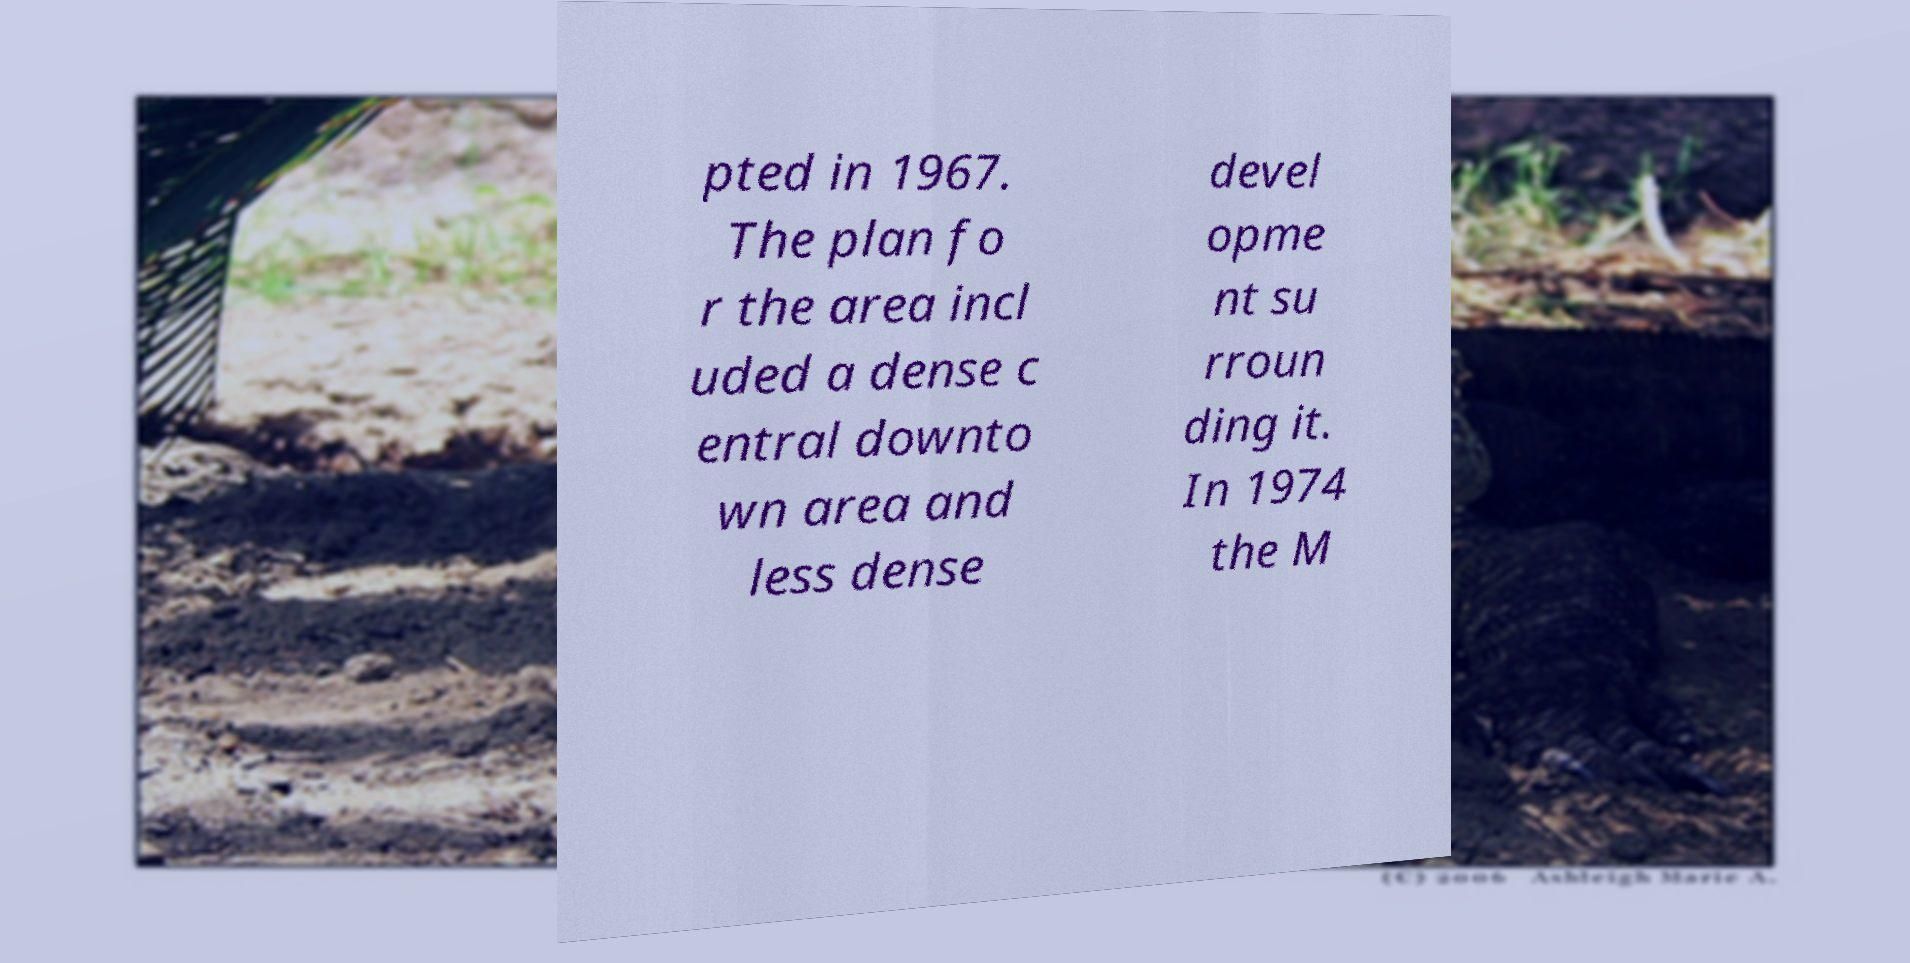Please read and relay the text visible in this image. What does it say? pted in 1967. The plan fo r the area incl uded a dense c entral downto wn area and less dense devel opme nt su rroun ding it. In 1974 the M 